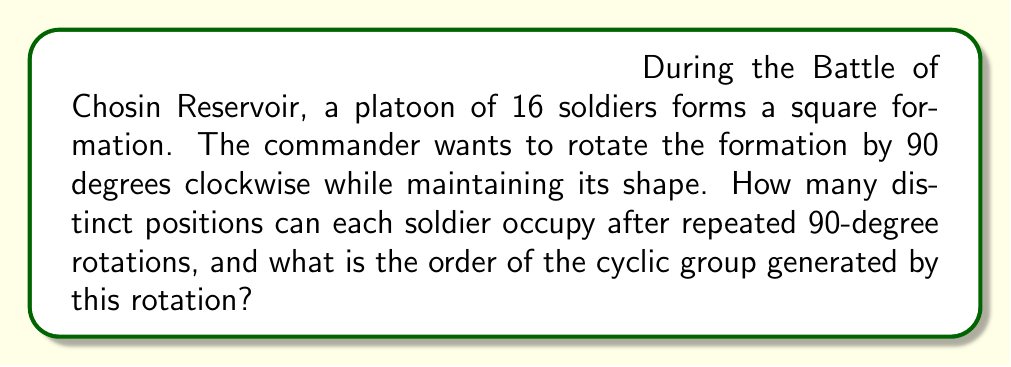What is the answer to this math problem? Let's approach this step-by-step using group theory and algebraic geometry:

1) First, we need to understand the symmetry of the square formation. A square has four rotational symmetries (0°, 90°, 180°, 270°), forming the cyclic group $C_4$.

2) The 90-degree rotation can be represented as a permutation of the soldiers' positions. Let's number the positions from 1 to 16, starting from the top-left corner and moving right and down:

   [asy]
   unitsize(0.5cm);
   for(int i=0; i<4; ++i)
     for(int j=0; j<4; ++j)
       label(string((i*4+j+1)), (j,-i));
   draw(square((0,0),(3,-3)));
   [/asy]

3) The 90-degree clockwise rotation permutes these positions as follows:
   $$(1,4,16,13)(2,8,15,9)(3,12,14,5)(6,7,11,10)$$

4) To find how many distinct positions each soldier can occupy, we need to find the length of the cycles in this permutation. We can see that there are:
   - 4 cycles of length 4
   - The center positions (6, 7, 10, 11) form a cycle of length 4

5) This means that each soldier will occupy exactly 4 distinct positions under repeated 90-degree rotations.

6) The order of the cyclic group generated by this rotation is determined by how many times we need to apply the rotation to get back to the original position. Since it takes 4 rotations to return to the starting position, the order of the group is 4.

This group is isomorphic to $C_4$, the cyclic group of order 4, which can be represented algebraically as $\mathbb{Z}/4\mathbb{Z}$ under addition modulo 4.
Answer: 4 distinct positions; order 4 